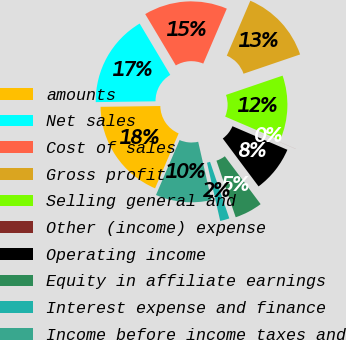Convert chart to OTSL. <chart><loc_0><loc_0><loc_500><loc_500><pie_chart><fcel>amounts<fcel>Net sales<fcel>Cost of sales<fcel>Gross profit<fcel>Selling general and<fcel>Other (income) expense<fcel>Operating income<fcel>Equity in affiliate earnings<fcel>Interest expense and finance<fcel>Income before income taxes and<nl><fcel>18.33%<fcel>16.66%<fcel>15.0%<fcel>13.33%<fcel>11.67%<fcel>0.01%<fcel>8.33%<fcel>5.0%<fcel>1.67%<fcel>10.0%<nl></chart> 